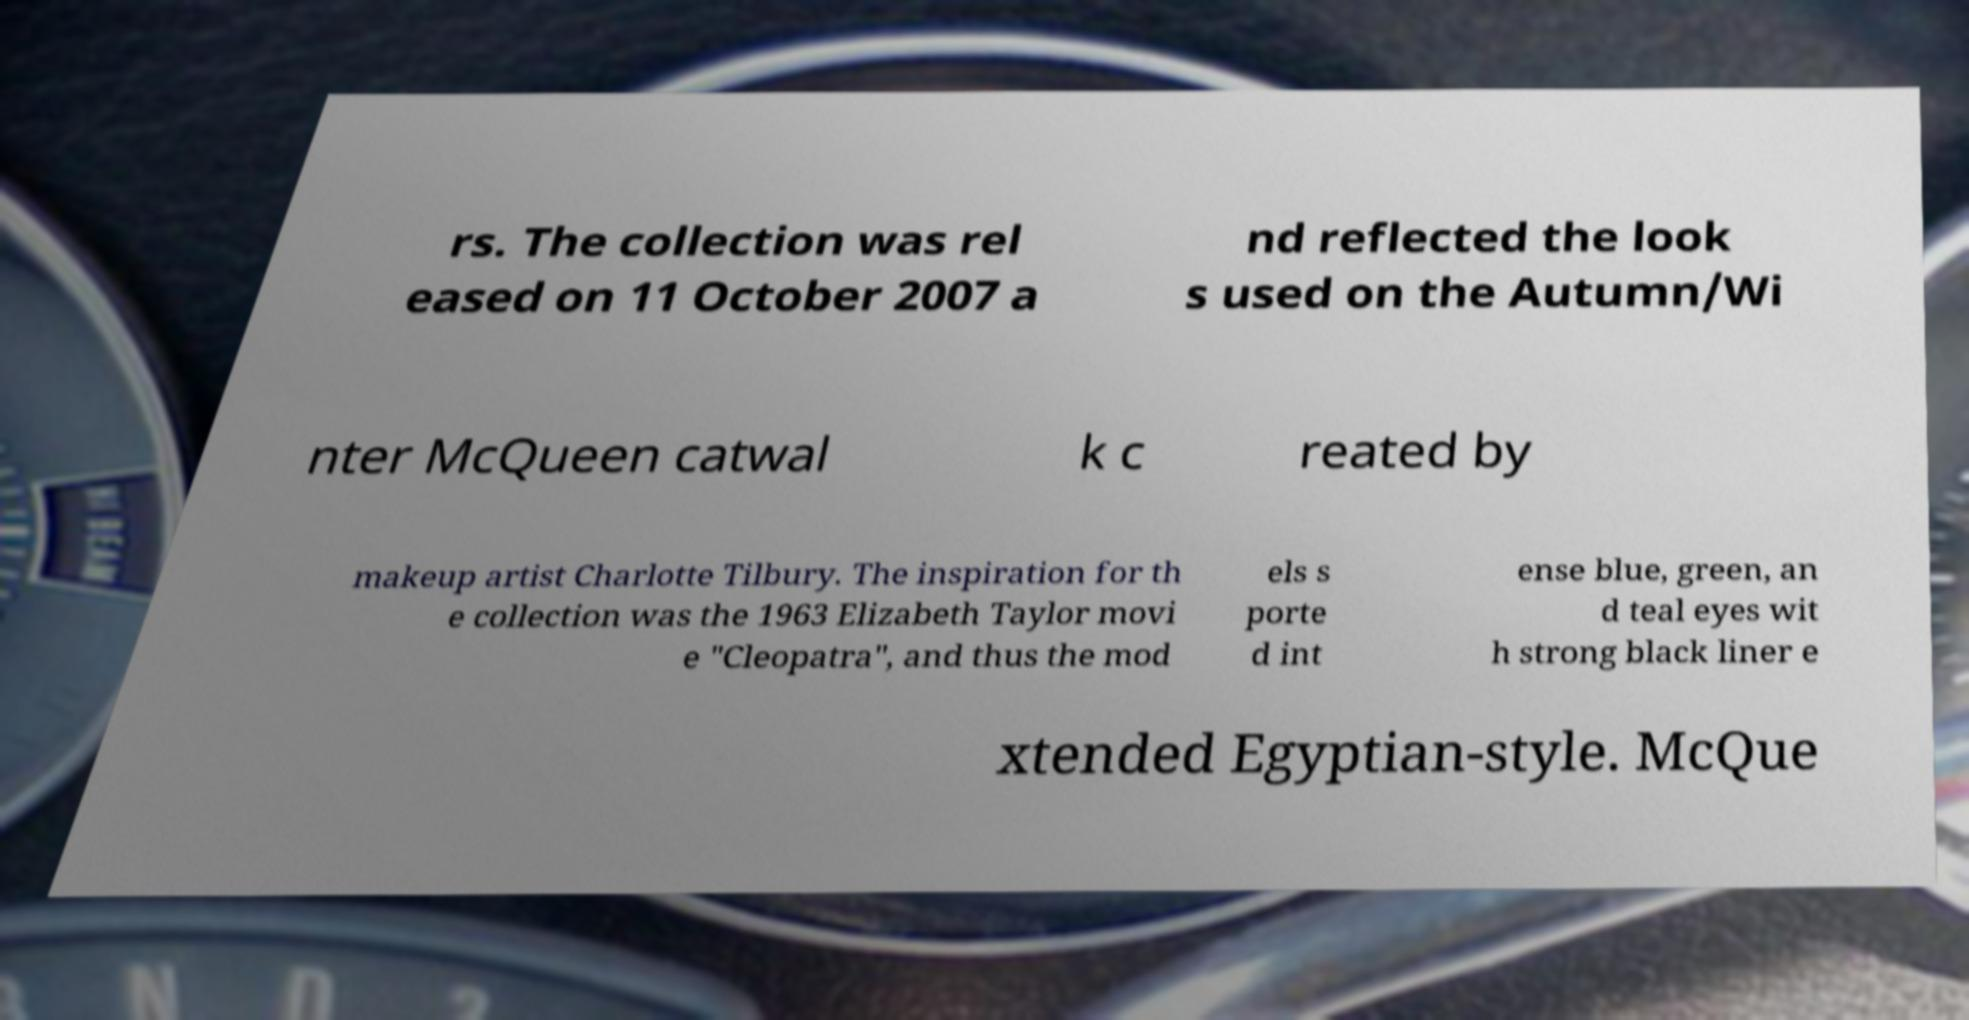Please identify and transcribe the text found in this image. rs. The collection was rel eased on 11 October 2007 a nd reflected the look s used on the Autumn/Wi nter McQueen catwal k c reated by makeup artist Charlotte Tilbury. The inspiration for th e collection was the 1963 Elizabeth Taylor movi e "Cleopatra", and thus the mod els s porte d int ense blue, green, an d teal eyes wit h strong black liner e xtended Egyptian-style. McQue 